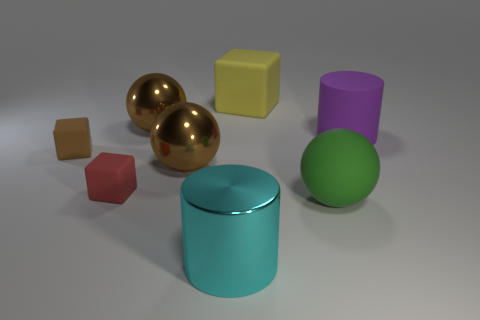Subtract all tiny blocks. How many blocks are left? 1 Subtract 1 cubes. How many cubes are left? 2 Add 1 large yellow rubber things. How many objects exist? 9 Subtract all blocks. How many objects are left? 5 Subtract all gray things. Subtract all big purple objects. How many objects are left? 7 Add 2 cyan metallic cylinders. How many cyan metallic cylinders are left? 3 Add 5 tiny brown matte things. How many tiny brown matte things exist? 6 Subtract 1 cyan cylinders. How many objects are left? 7 